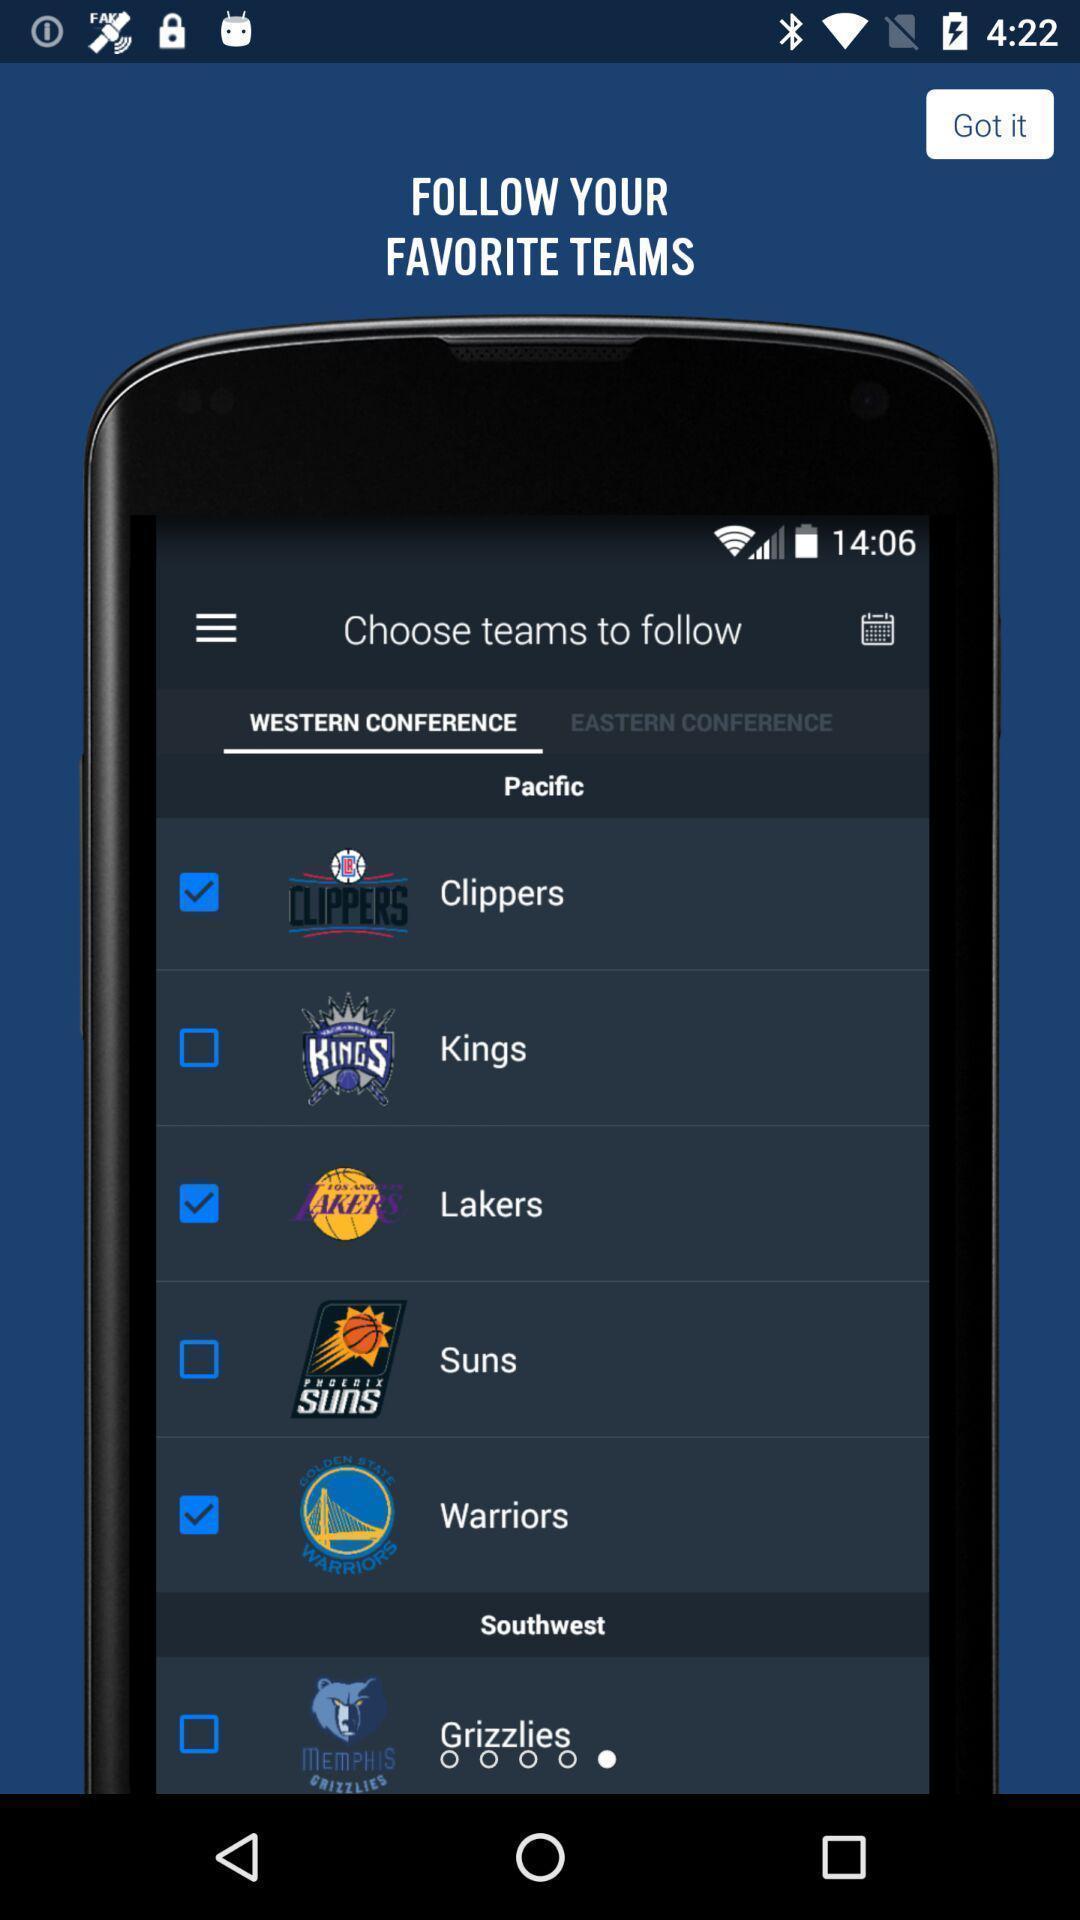Give me a narrative description of this picture. Screen displaying about the favorite teams to follow. 